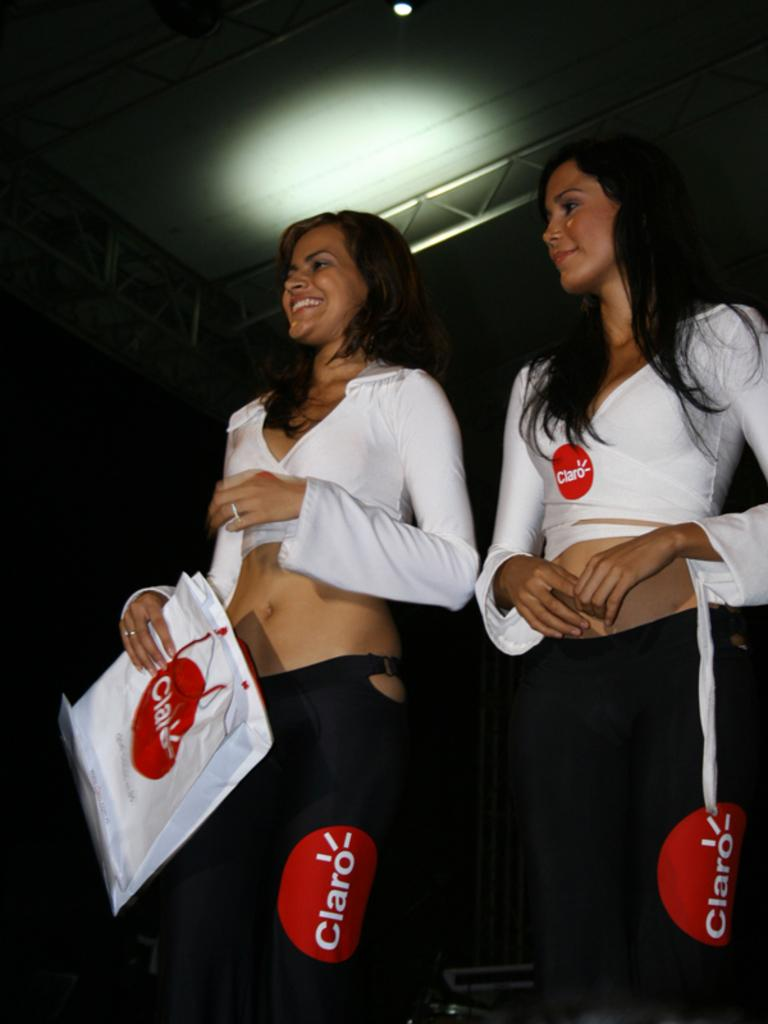<image>
Share a concise interpretation of the image provided. 2 women wearing black pants with a red circle with Claro written in white. 